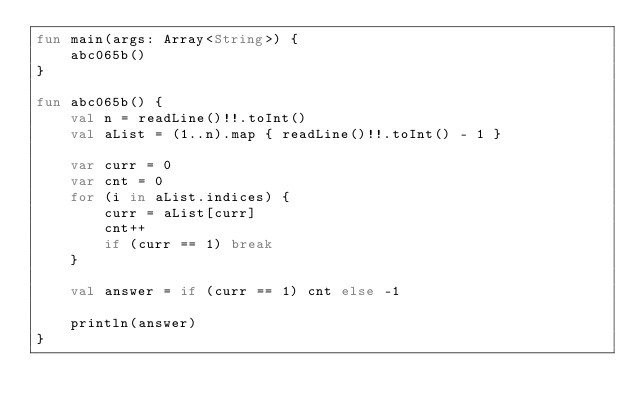Convert code to text. <code><loc_0><loc_0><loc_500><loc_500><_Kotlin_>fun main(args: Array<String>) {
    abc065b()
}

fun abc065b() {
    val n = readLine()!!.toInt()
    val aList = (1..n).map { readLine()!!.toInt() - 1 }

    var curr = 0
    var cnt = 0
    for (i in aList.indices) {
        curr = aList[curr]
        cnt++
        if (curr == 1) break
    }

    val answer = if (curr == 1) cnt else -1

    println(answer)
}
</code> 